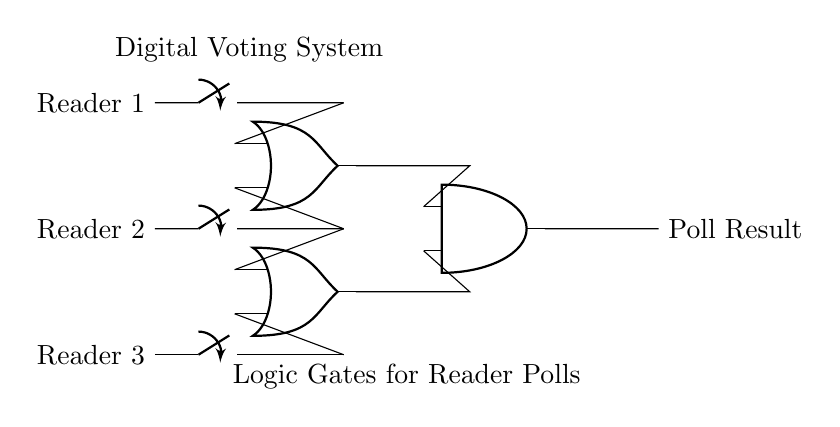what components are in this circuit? The components include three switches, two OR gates, and one AND gate. This can be identified by looking at the diagram and counting each unique type of component.
Answer: three switches, two OR gates, one AND gate how many inputs are there for the AND gate? The AND gate has two inputs, which come from the outputs of the two OR gates. This is determined by examining the connections leading into the AND gate.
Answer: two inputs what is the purpose of the OR gates in this circuit? The OR gates are used to combine the signals from multiple readers, allowing any reader's input to affect the outcome. This is inferred from the fact that if any switch is ON, the OR gate will produce a positive output.
Answer: combining signals if all readers vote "yes," what will be the output? If all readers vote "yes," the output of both OR gates will be high, leading the AND gate to also output high. This follows from the function of the AND gate, which only outputs high if both its inputs are high.
Answer: yes what happens if two readers vote "yes" and one votes "no"? If two readers vote "yes" and one votes "no," at least one OR gate will output high, thus allowing the AND gate's output to also be high, permitting a "yes" vote overall. This is because the OR gates will capture the two "yes" votes.
Answer: yes which logical operation does the last element perform? The last element performs an AND operation, as indicated by the symbol representing the AND gate in the diagram. This operation requires both inputs to be high for the output to be high.
Answer: AND operation 